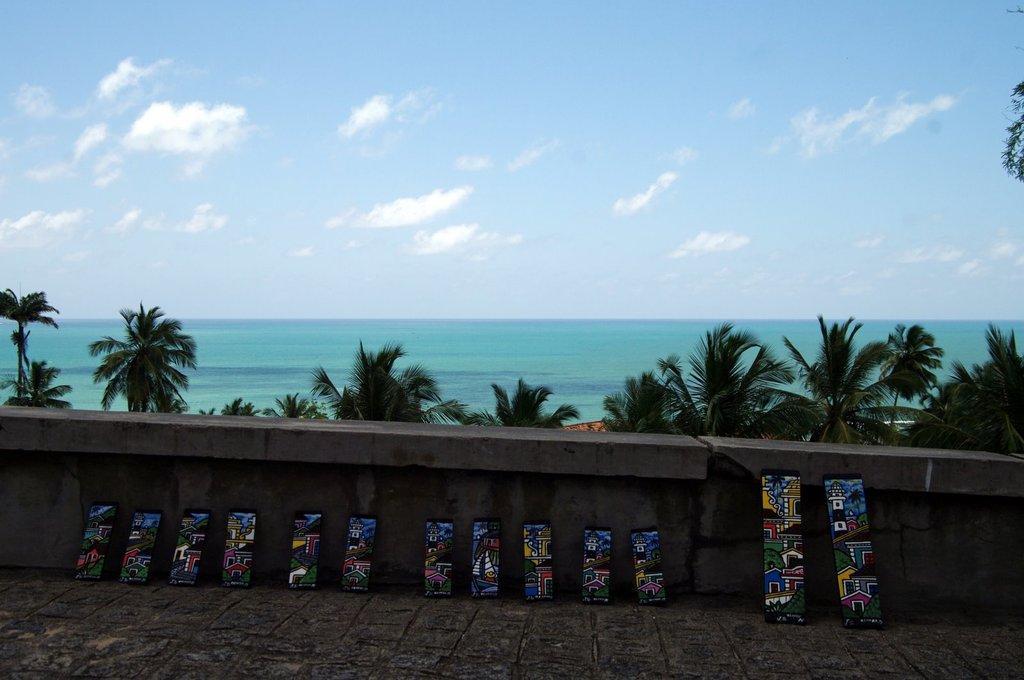Please provide a concise description of this image. There are a lot of skating pads laid to the wall and behind the wall there are lot of trees and in the background there is a sea. 